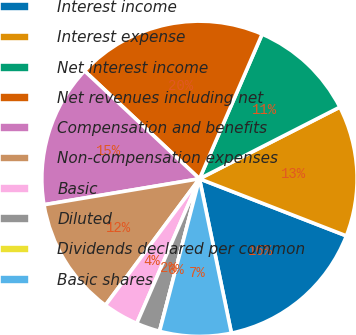<chart> <loc_0><loc_0><loc_500><loc_500><pie_chart><fcel>Interest income<fcel>Interest expense<fcel>Net interest income<fcel>Net revenues including net<fcel>Compensation and benefits<fcel>Non-compensation expenses<fcel>Basic<fcel>Diluted<fcel>Dividends declared per common<fcel>Basic shares<nl><fcel>15.85%<fcel>13.41%<fcel>10.98%<fcel>19.51%<fcel>14.63%<fcel>12.19%<fcel>3.66%<fcel>2.44%<fcel>0.0%<fcel>7.32%<nl></chart> 